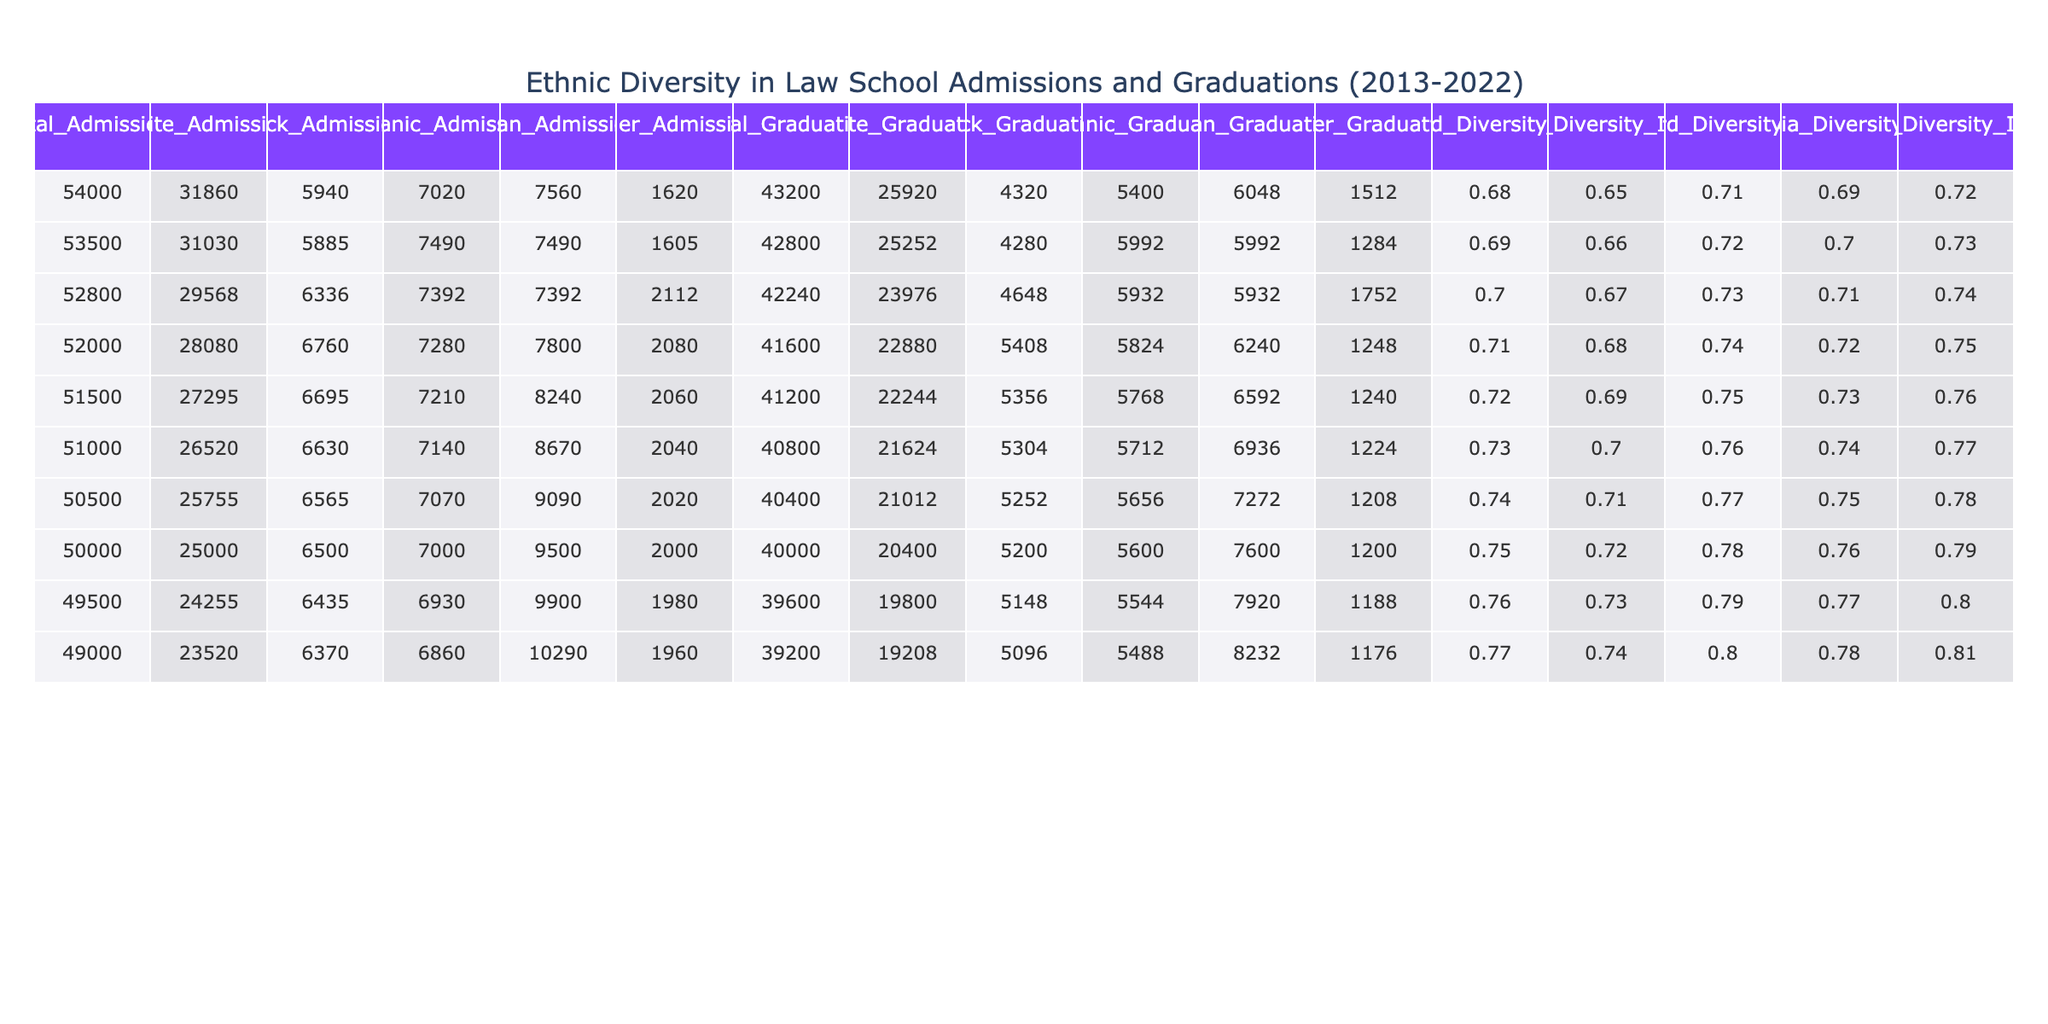What was the total number of admissions in 2019? Referring to the table data for the year 2019, the Total Admissions column shows a value of 50500.
Answer: 50500 How many Black students were admitted in 2021? In the year 2021, the Black Admissions column shows a value of 6435.
Answer: 6435 What is the difference in total admissions between 2013 and 2022? The Total Admissions in 2013 is 54000 and in 2022 is 49000. The difference is 54000 - 49000 = 5000.
Answer: 5000 Which year had the highest number of White admissions? Checking the White Admissions column, the highest value is 31860 in the year 2013.
Answer: 2013 What percentage of total admissions were Hispanic in 2016? For 2016, Hispanic Admissions is 7280, and Total Admissions is 52000. The percentage is (7280 / 52000) * 100 ≈ 13.98%.
Answer: 13.98% In which year did the number of Asian admissions exceed 9000? Looking at the Asian Admissions column, the numbers for each year show that Asian admissions exceed 9000 only in the years 2019, 2020, 2021, and 2022.
Answer: 2019, 2020, 2021, 2022 True or False: The Harvard Diversity Index increased every year from 2013 to 2022. By examining the Harvard Diversity Index, it increases from 0.68 in 2013 to 0.77 in 2022, confirming that it increased every year.
Answer: True What was the trend in the number of Black graduations from 2013 to 2022? Looking at the Black Graduations column, there is a fluctuation but a general downward trend from 4320 in 2013 to 5096 in 2022, indicating that the number did not consistently decline.
Answer: General downward trend What is the average percentage of Hispanic admissions across all years? The sum of Hispanic Admissions from 2013 to 2022 is (7020 + 7490 + 7392 + 7280 + 7210 + 7140 + 7070 + 7000 + 6930 + 6860 = 69942) and the total admissions across all years is 490000. The average percentage is (69942 / 490000) * 100 ≈ 14.25%.
Answer: 14.25% What was the ratio of Black admissions to total admissions in the year 2015? In 2015, Black Admissions was 6336 and Total Admissions was 52800. The ratio is 6336:52800, which simplifies to approximately 1:8.33.
Answer: 1:8.33 